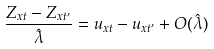Convert formula to latex. <formula><loc_0><loc_0><loc_500><loc_500>\frac { Z _ { x t } - Z _ { x t ^ { \prime } } } { \hat { \lambda } } = u _ { x t } - u _ { x t ^ { \prime } } + O ( \hat { \lambda } )</formula> 